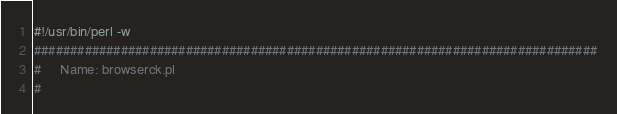Convert code to text. <code><loc_0><loc_0><loc_500><loc_500><_Perl_>#!/usr/bin/perl -w
##############################################################################
#     Name: browserck.pl
#</code> 